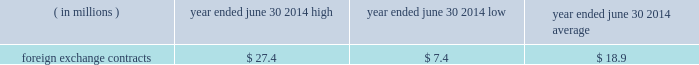Version 5 2022 9/11/14 2022 last revised by : saul bernstein 68 the est{e lauder companies inc .
Correlations calculated over the past 250-day period .
The high , low and average measured value-at-risk during fiscal 2014 related to our foreign exchange contracts is as follows: .
Foreign exchange contracts $ 27.4 $ 7.4 $ 18.9 the model estimates were made assuming normal market conditions and a 95 percent confidence level .
We used a statistical simulation model that valued our derivative financial instruments against one thousand randomly gen- erated market price paths .
Our calculated value-at-risk exposure represents an estimate of reasonably possible net losses that would be recognized on our portfolio of derivative financial instruments assuming hypothetical movements in future market rates and is not necessarily indicative of actual results , which may or may not occur .
It does not represent the maximum possible loss or any expected loss that may occur , since actual future gains and losses will differ from those estimated , based upon actual fluctuations in market rates , operating exposures , and the timing thereof , and changes in our portfolio of derivative financial instruments during the year .
We believe , however , that any such loss incurred would be offset by the effects of market rate movements on the respective underlying transactions for which the deriva- tive financial instrument was intended .
Off-balance sheet arrangements we do not maintain any off-balance sheet arrangements , transactions , obligations or other relationships with unconsolidated entities , other than operating leases , that would be expected to have a material current or future effect upon our financial condition or results of operations .
Recently issued accounting standards refer to 201cnote 2 2014 summary of significant accounting policies 201d of notes to consolidated financial statements for discussion regarding the impact of accounting stan- dards that were recently issued but not yet effective , on our consolidated financial statements .
Forward-looking information we and our representatives from time to time make written or oral forward-looking statements , including statements contained in this and other filings with the securities and exchange commission , in our press releases and in our reports to stockholders .
The words and phrases 201cwill likely result , 201d 201cexpect , 201d 201cbelieve , 201d 201cplanned , 201d 201cmay , 201d 201cshould , 201d 201ccould , 201d 201canticipate , 201d 201cestimate , 201d 201cproject , 201d 201cintend , 201d 201cforecast 201d or similar expressions are intended to identify 201cforward-looking statements 201d within the meaning of the private securities litigation reform act of 1995 .
These statements include , without limitation , our expectations regarding sales , earn- ings or other future financial performance and liquidity , product introductions , entry into new geographic regions , information systems initiatives , new methods of sale , our long-term strategy , restructuring and other charges and resulting cost savings , and future operations or operating results .
Although we believe that our expectations are based on reasonable assumptions within the bounds of our knowledge of our business and operations , actual results may differ materially from our expectations .
Factors that could cause actual results to differ from expectations include , without limitation : ( 1 ) increased competitive activity from companies in the skin care , makeup , fragrance and hair care businesses , some of which have greater resources than we do ; ( 2 ) our ability to develop , produce and market new prod- ucts on which future operating results may depend and to successfully address challenges in our business ; ( 3 ) consolidations , restructurings , bankruptcies and reorganizations in the retail industry causing a decrease in the number of stores that sell our products , an increase in the ownership concentration within the retail industry , ownership of retailers by our competitors or ownership of competitors by our customers that are retailers and our inability to collect receivables ; ( 4 ) destocking and tighter working capital management by retailers ; ( 5 ) the success , or changes in timing or scope , of new product launches and the success , or changes in the tim- ing or the scope , of advertising , sampling and merchan- dising programs ; ( 6 ) shifts in the preferences of consumers as to where and how they shop for the types of products and services we sell ; ( 7 ) social , political and economic risks to our foreign or domestic manufacturing , distribution and retail opera- tions , including changes in foreign investment and trade policies and regulations of the host countries and of the united states ; 77840es_fin.indd 68 9/12/14 5:11 pm .
What is the variation observed in the low and average foreign exchange contracts , in millions of dollars? 
Rationale: it is the difference between those values .
Computations: (18.9 - 7.4)
Answer: 11.5. 